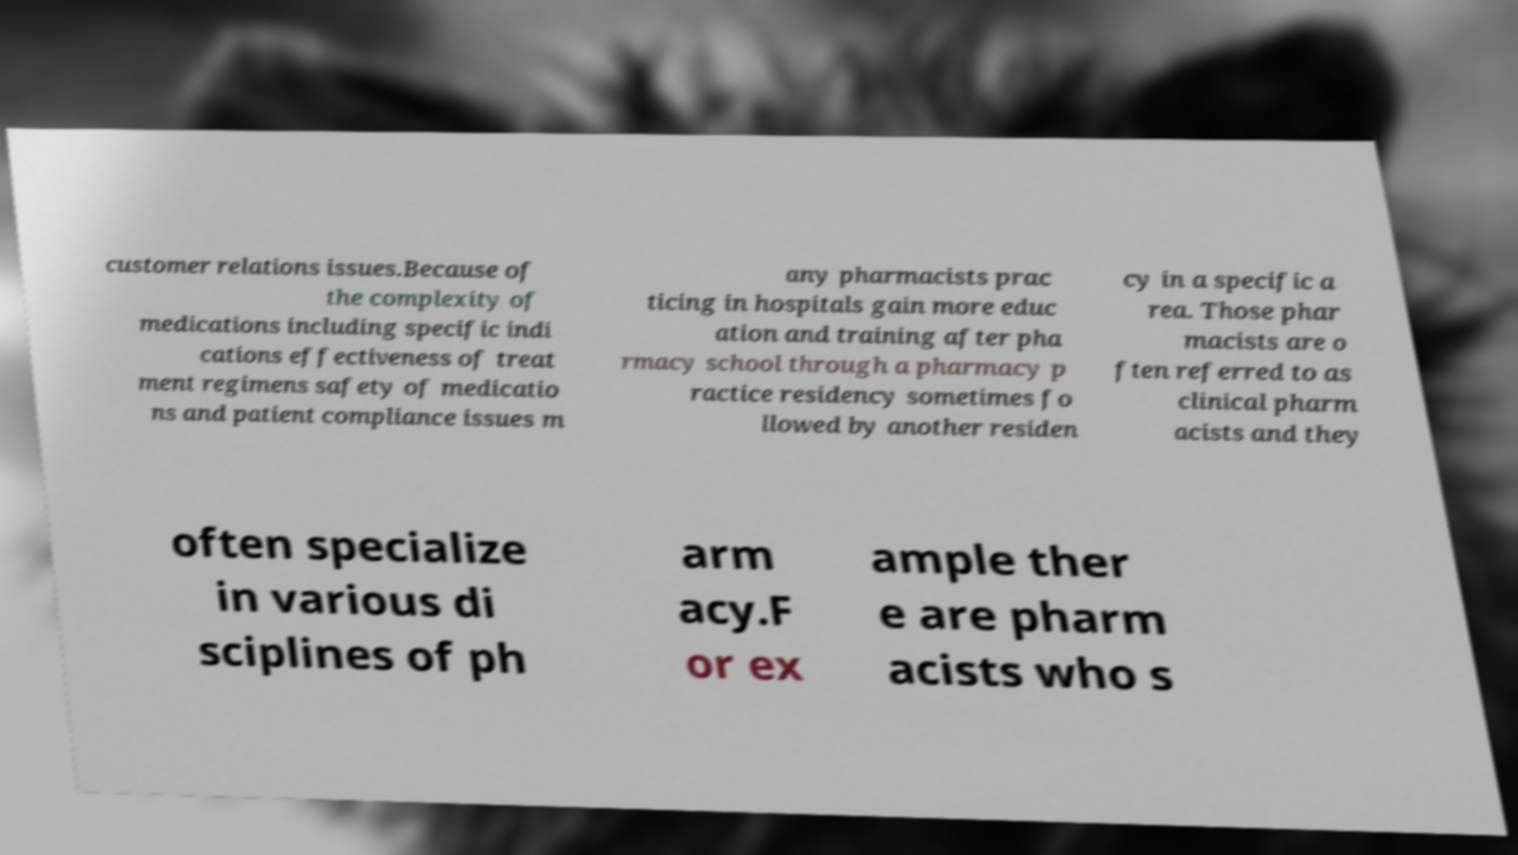For documentation purposes, I need the text within this image transcribed. Could you provide that? customer relations issues.Because of the complexity of medications including specific indi cations effectiveness of treat ment regimens safety of medicatio ns and patient compliance issues m any pharmacists prac ticing in hospitals gain more educ ation and training after pha rmacy school through a pharmacy p ractice residency sometimes fo llowed by another residen cy in a specific a rea. Those phar macists are o ften referred to as clinical pharm acists and they often specialize in various di sciplines of ph arm acy.F or ex ample ther e are pharm acists who s 